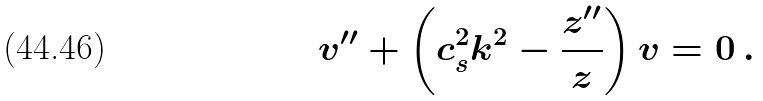Convert formula to latex. <formula><loc_0><loc_0><loc_500><loc_500>v ^ { \prime \prime } + \left ( c _ { s } ^ { 2 } k ^ { 2 } - \frac { z ^ { \prime \prime } } { z } \right ) v = 0 \, .</formula> 